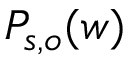Convert formula to latex. <formula><loc_0><loc_0><loc_500><loc_500>P _ { s , o } ( w )</formula> 